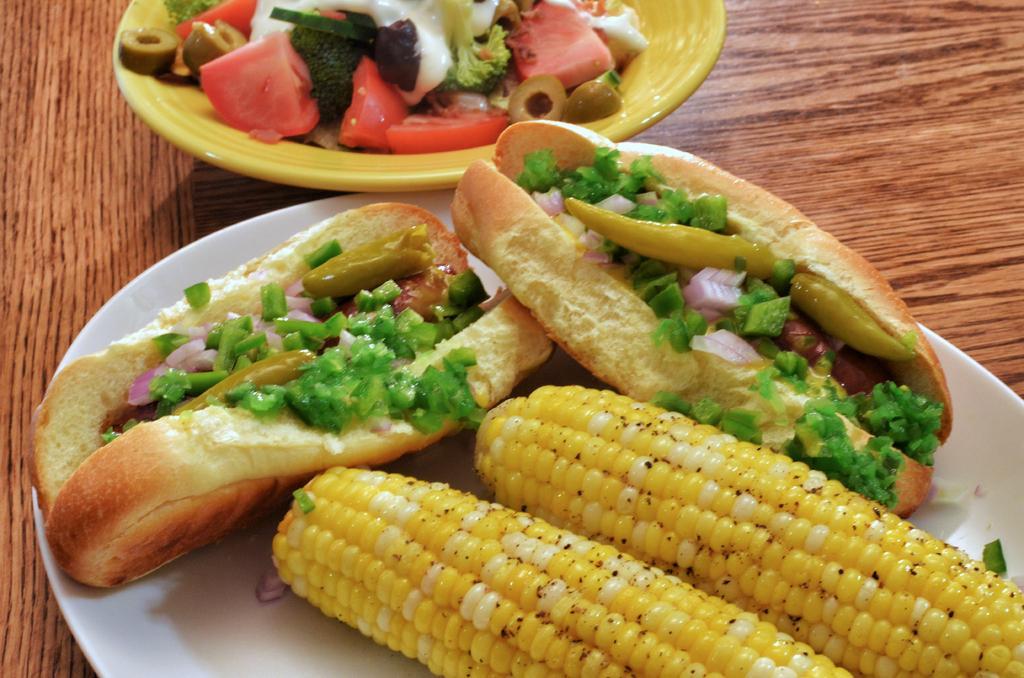How would you summarize this image in a sentence or two? In this image we can see two plates on a surface. On the plates we can see the variety of food. 